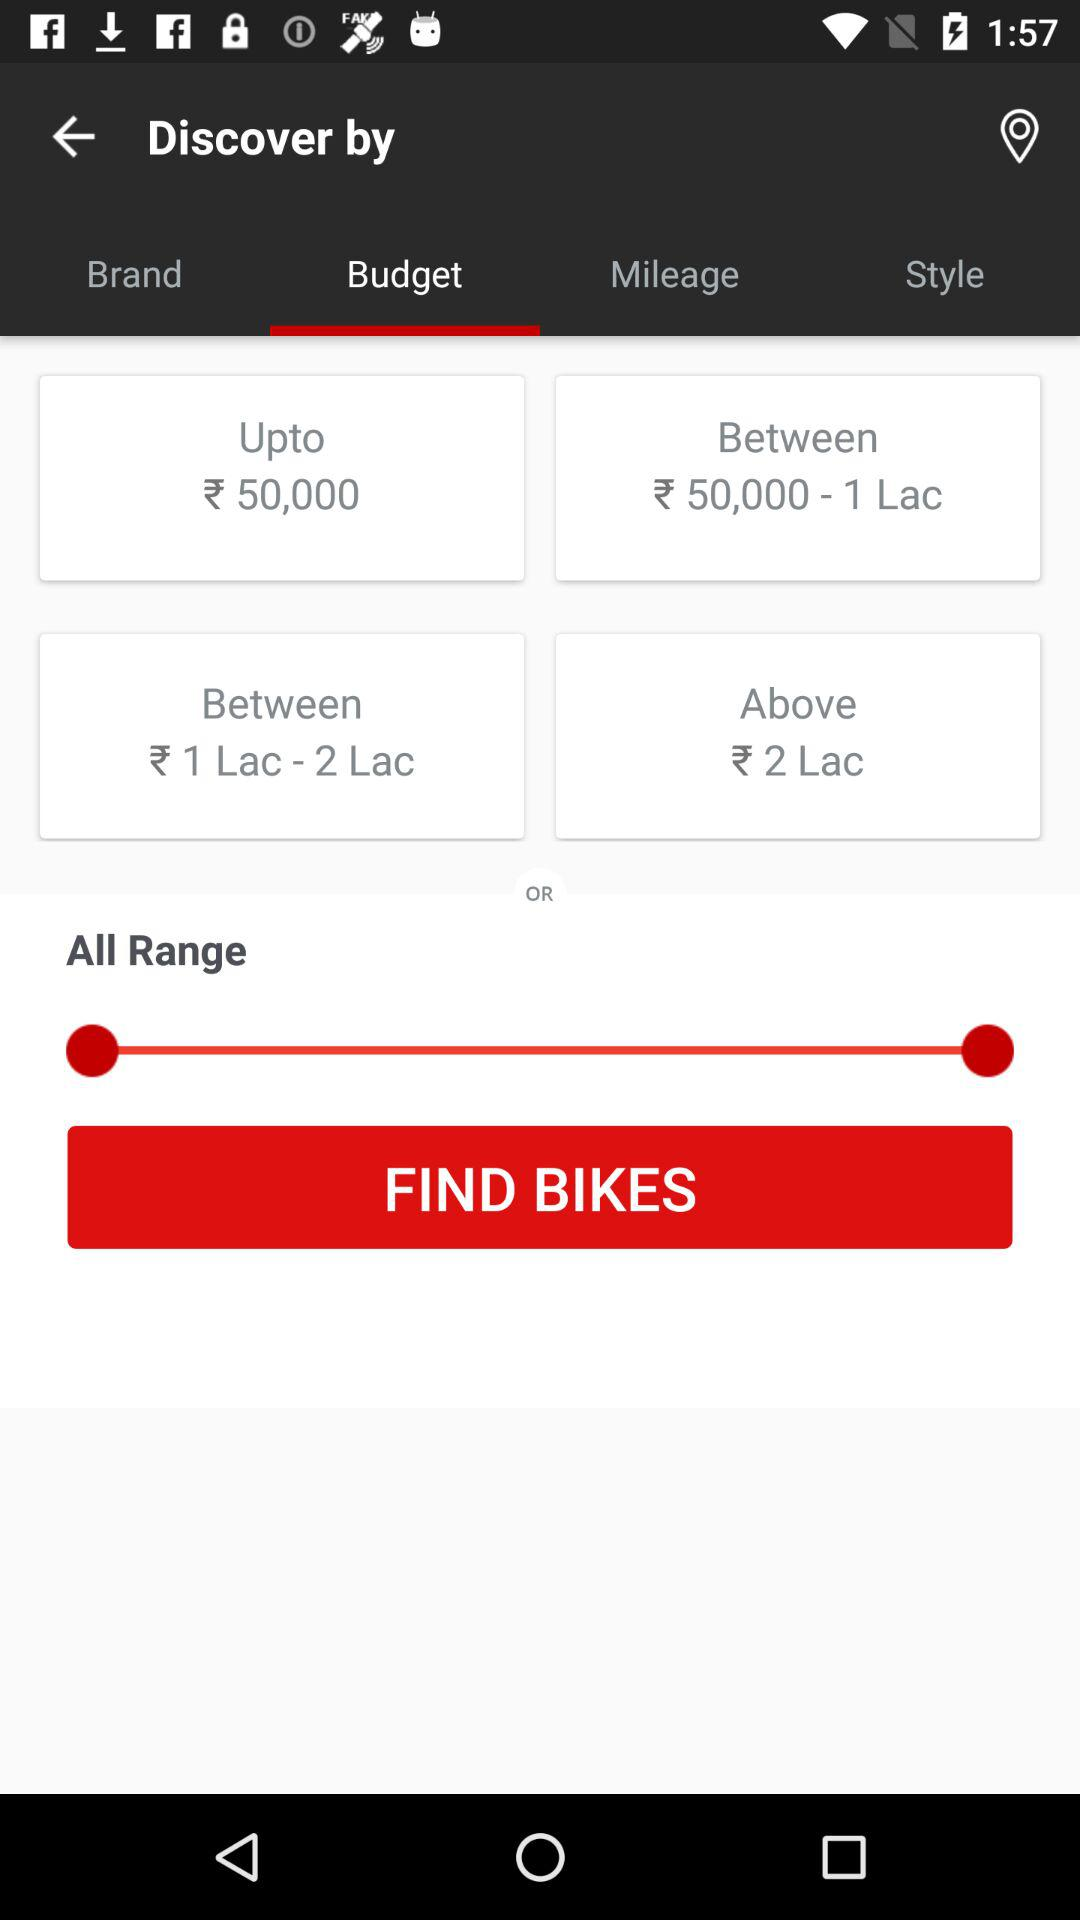Which tab is selected? The selected tab is "Budget". 